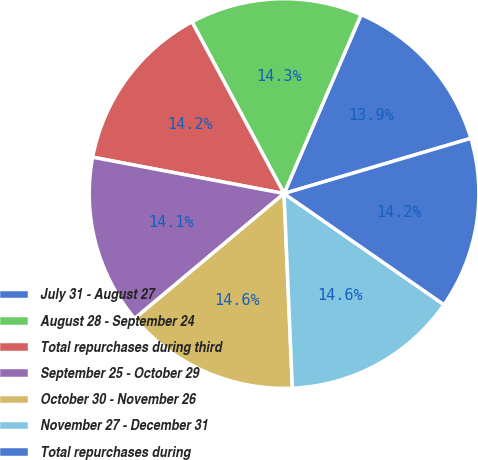<chart> <loc_0><loc_0><loc_500><loc_500><pie_chart><fcel>July 31 - August 27<fcel>August 28 - September 24<fcel>Total repurchases during third<fcel>September 25 - October 29<fcel>October 30 - November 26<fcel>November 27 - December 31<fcel>Total repurchases during<nl><fcel>13.95%<fcel>14.31%<fcel>14.18%<fcel>14.08%<fcel>14.59%<fcel>14.65%<fcel>14.24%<nl></chart> 